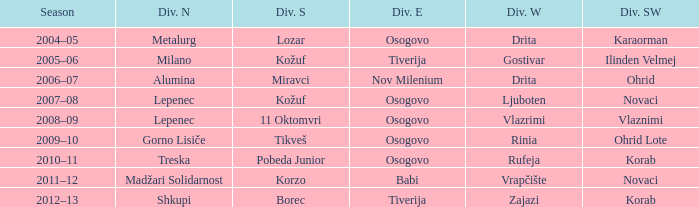Who won Division Southwest when the winner of Division North was Lepenec and Division South was won by 11 Oktomvri? Vlaznimi. 